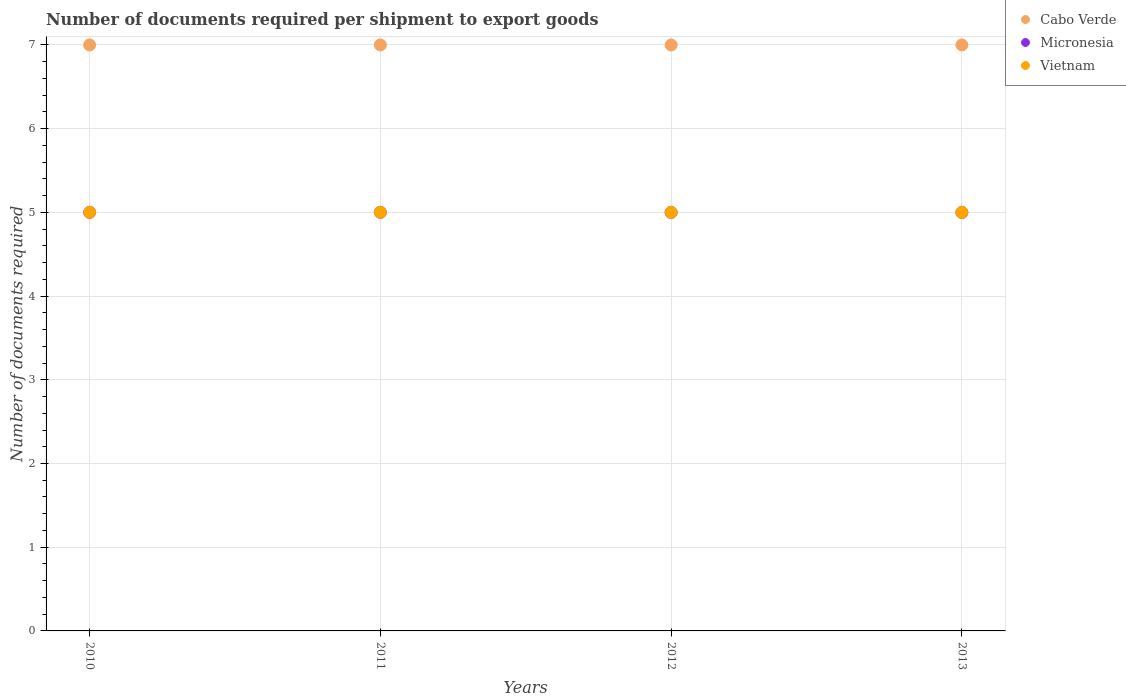How many different coloured dotlines are there?
Your answer should be very brief. 3. Is the number of dotlines equal to the number of legend labels?
Offer a very short reply. Yes. What is the number of documents required per shipment to export goods in Vietnam in 2011?
Your answer should be compact. 5. Across all years, what is the maximum number of documents required per shipment to export goods in Cabo Verde?
Your answer should be very brief. 7. Across all years, what is the minimum number of documents required per shipment to export goods in Vietnam?
Your response must be concise. 5. In which year was the number of documents required per shipment to export goods in Vietnam maximum?
Offer a very short reply. 2010. In which year was the number of documents required per shipment to export goods in Micronesia minimum?
Your response must be concise. 2010. What is the total number of documents required per shipment to export goods in Cabo Verde in the graph?
Give a very brief answer. 28. What is the difference between the number of documents required per shipment to export goods in Micronesia in 2010 and that in 2011?
Make the answer very short. 0. What is the difference between the number of documents required per shipment to export goods in Vietnam in 2011 and the number of documents required per shipment to export goods in Cabo Verde in 2010?
Your answer should be compact. -2. What is the average number of documents required per shipment to export goods in Cabo Verde per year?
Ensure brevity in your answer.  7. In the year 2011, what is the difference between the number of documents required per shipment to export goods in Cabo Verde and number of documents required per shipment to export goods in Micronesia?
Offer a terse response. 2. Is the difference between the number of documents required per shipment to export goods in Cabo Verde in 2011 and 2013 greater than the difference between the number of documents required per shipment to export goods in Micronesia in 2011 and 2013?
Make the answer very short. No. What is the difference between the highest and the second highest number of documents required per shipment to export goods in Cabo Verde?
Keep it short and to the point. 0. What is the difference between the highest and the lowest number of documents required per shipment to export goods in Cabo Verde?
Offer a terse response. 0. In how many years, is the number of documents required per shipment to export goods in Micronesia greater than the average number of documents required per shipment to export goods in Micronesia taken over all years?
Make the answer very short. 0. Is the sum of the number of documents required per shipment to export goods in Micronesia in 2010 and 2013 greater than the maximum number of documents required per shipment to export goods in Cabo Verde across all years?
Provide a short and direct response. Yes. Is it the case that in every year, the sum of the number of documents required per shipment to export goods in Micronesia and number of documents required per shipment to export goods in Cabo Verde  is greater than the number of documents required per shipment to export goods in Vietnam?
Your answer should be very brief. Yes. How many dotlines are there?
Keep it short and to the point. 3. Does the graph contain grids?
Keep it short and to the point. Yes. Where does the legend appear in the graph?
Provide a succinct answer. Top right. How many legend labels are there?
Offer a terse response. 3. What is the title of the graph?
Ensure brevity in your answer.  Number of documents required per shipment to export goods. Does "Barbados" appear as one of the legend labels in the graph?
Make the answer very short. No. What is the label or title of the X-axis?
Make the answer very short. Years. What is the label or title of the Y-axis?
Keep it short and to the point. Number of documents required. What is the Number of documents required of Micronesia in 2010?
Your answer should be very brief. 5. What is the Number of documents required in Vietnam in 2010?
Offer a terse response. 5. What is the Number of documents required of Cabo Verde in 2011?
Provide a short and direct response. 7. What is the Number of documents required of Micronesia in 2011?
Give a very brief answer. 5. What is the Number of documents required of Cabo Verde in 2012?
Keep it short and to the point. 7. What is the Number of documents required in Micronesia in 2013?
Make the answer very short. 5. Across all years, what is the maximum Number of documents required in Cabo Verde?
Offer a terse response. 7. Across all years, what is the maximum Number of documents required in Micronesia?
Offer a terse response. 5. Across all years, what is the minimum Number of documents required of Cabo Verde?
Your response must be concise. 7. Across all years, what is the minimum Number of documents required in Micronesia?
Give a very brief answer. 5. Across all years, what is the minimum Number of documents required in Vietnam?
Offer a very short reply. 5. What is the total Number of documents required in Cabo Verde in the graph?
Your answer should be compact. 28. What is the total Number of documents required of Vietnam in the graph?
Provide a short and direct response. 20. What is the difference between the Number of documents required in Cabo Verde in 2010 and that in 2011?
Your answer should be very brief. 0. What is the difference between the Number of documents required of Vietnam in 2010 and that in 2011?
Your answer should be very brief. 0. What is the difference between the Number of documents required in Vietnam in 2010 and that in 2013?
Provide a succinct answer. 0. What is the difference between the Number of documents required of Micronesia in 2011 and that in 2012?
Give a very brief answer. 0. What is the difference between the Number of documents required of Micronesia in 2011 and that in 2013?
Make the answer very short. 0. What is the difference between the Number of documents required of Vietnam in 2011 and that in 2013?
Offer a terse response. 0. What is the difference between the Number of documents required of Micronesia in 2012 and that in 2013?
Keep it short and to the point. 0. What is the difference between the Number of documents required in Vietnam in 2012 and that in 2013?
Give a very brief answer. 0. What is the difference between the Number of documents required in Cabo Verde in 2010 and the Number of documents required in Micronesia in 2011?
Offer a very short reply. 2. What is the difference between the Number of documents required in Cabo Verde in 2010 and the Number of documents required in Micronesia in 2012?
Offer a terse response. 2. What is the difference between the Number of documents required of Cabo Verde in 2010 and the Number of documents required of Vietnam in 2012?
Offer a terse response. 2. What is the difference between the Number of documents required of Micronesia in 2010 and the Number of documents required of Vietnam in 2012?
Give a very brief answer. 0. What is the difference between the Number of documents required of Cabo Verde in 2010 and the Number of documents required of Micronesia in 2013?
Offer a terse response. 2. What is the difference between the Number of documents required in Micronesia in 2010 and the Number of documents required in Vietnam in 2013?
Make the answer very short. 0. What is the difference between the Number of documents required of Micronesia in 2011 and the Number of documents required of Vietnam in 2012?
Your response must be concise. 0. What is the difference between the Number of documents required of Cabo Verde in 2011 and the Number of documents required of Micronesia in 2013?
Your answer should be very brief. 2. What is the difference between the Number of documents required of Micronesia in 2011 and the Number of documents required of Vietnam in 2013?
Your answer should be very brief. 0. What is the difference between the Number of documents required in Cabo Verde in 2012 and the Number of documents required in Micronesia in 2013?
Offer a very short reply. 2. What is the difference between the Number of documents required in Micronesia in 2012 and the Number of documents required in Vietnam in 2013?
Provide a short and direct response. 0. In the year 2010, what is the difference between the Number of documents required in Cabo Verde and Number of documents required in Vietnam?
Offer a very short reply. 2. In the year 2010, what is the difference between the Number of documents required of Micronesia and Number of documents required of Vietnam?
Offer a very short reply. 0. In the year 2012, what is the difference between the Number of documents required of Cabo Verde and Number of documents required of Micronesia?
Keep it short and to the point. 2. In the year 2012, what is the difference between the Number of documents required of Cabo Verde and Number of documents required of Vietnam?
Ensure brevity in your answer.  2. In the year 2013, what is the difference between the Number of documents required in Cabo Verde and Number of documents required in Vietnam?
Give a very brief answer. 2. In the year 2013, what is the difference between the Number of documents required in Micronesia and Number of documents required in Vietnam?
Your response must be concise. 0. What is the ratio of the Number of documents required in Vietnam in 2010 to that in 2012?
Provide a short and direct response. 1. What is the ratio of the Number of documents required in Micronesia in 2011 to that in 2012?
Offer a very short reply. 1. What is the ratio of the Number of documents required of Vietnam in 2011 to that in 2012?
Offer a very short reply. 1. What is the ratio of the Number of documents required in Micronesia in 2011 to that in 2013?
Your answer should be very brief. 1. What is the ratio of the Number of documents required of Vietnam in 2011 to that in 2013?
Your response must be concise. 1. What is the difference between the highest and the second highest Number of documents required in Cabo Verde?
Offer a terse response. 0. What is the difference between the highest and the second highest Number of documents required of Micronesia?
Ensure brevity in your answer.  0. What is the difference between the highest and the lowest Number of documents required in Cabo Verde?
Give a very brief answer. 0. What is the difference between the highest and the lowest Number of documents required in Micronesia?
Offer a very short reply. 0. What is the difference between the highest and the lowest Number of documents required in Vietnam?
Your response must be concise. 0. 